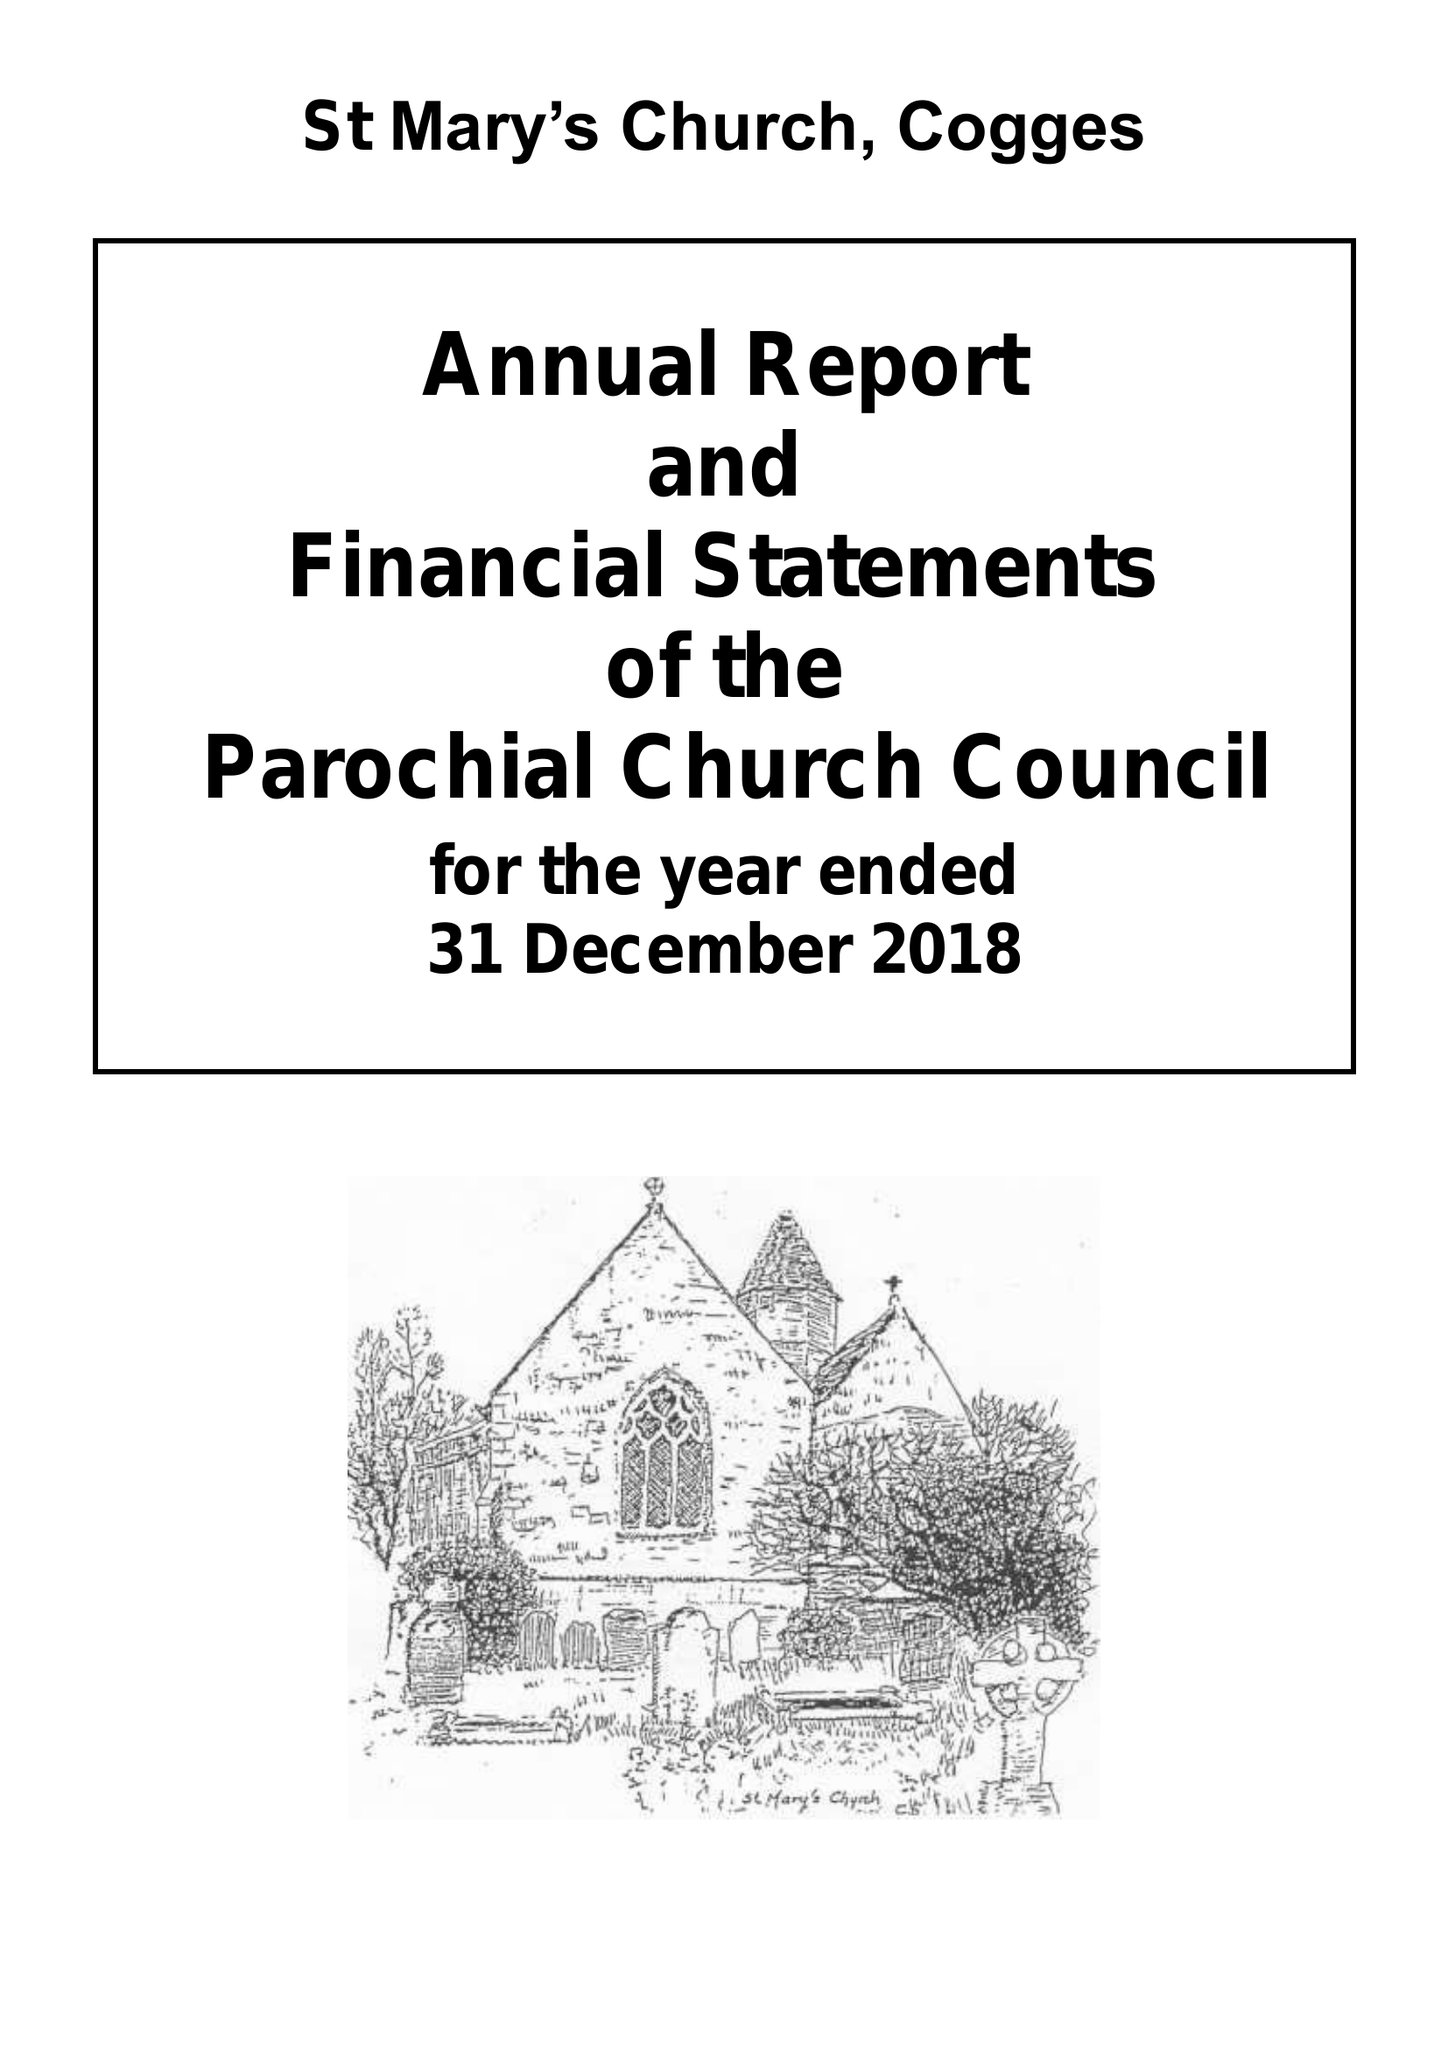What is the value for the charity_name?
Answer the question using a single word or phrase. The Parochial Church Council Of The Ecclesiastical Parish Of St Mary Cogges 